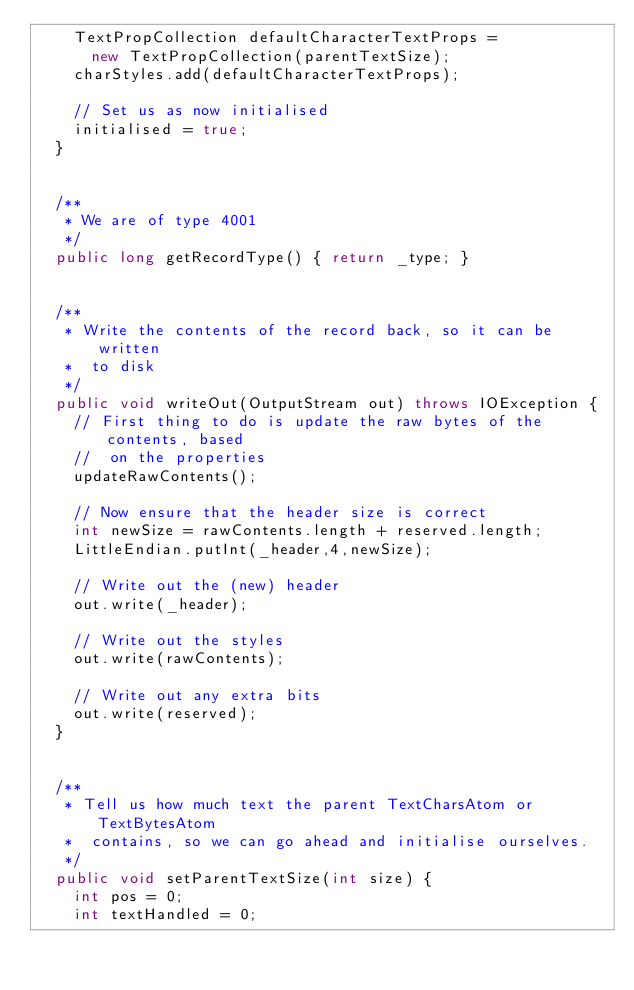Convert code to text. <code><loc_0><loc_0><loc_500><loc_500><_Java_>		TextPropCollection defaultCharacterTextProps =
			new TextPropCollection(parentTextSize);
		charStyles.add(defaultCharacterTextProps);

		// Set us as now initialised
		initialised = true;
	}


	/**
	 * We are of type 4001
	 */
	public long getRecordType() { return _type; }


	/**
	 * Write the contents of the record back, so it can be written
	 *  to disk
	 */
	public void writeOut(OutputStream out) throws IOException {
		// First thing to do is update the raw bytes of the contents, based
		//  on the properties
		updateRawContents();

		// Now ensure that the header size is correct
		int newSize = rawContents.length + reserved.length;
		LittleEndian.putInt(_header,4,newSize);

		// Write out the (new) header
		out.write(_header);

		// Write out the styles
		out.write(rawContents);

		// Write out any extra bits
		out.write(reserved);
	}


	/**
	 * Tell us how much text the parent TextCharsAtom or TextBytesAtom
	 *  contains, so we can go ahead and initialise ourselves.
	 */
	public void setParentTextSize(int size) {
		int pos = 0;
		int textHandled = 0;
</code> 